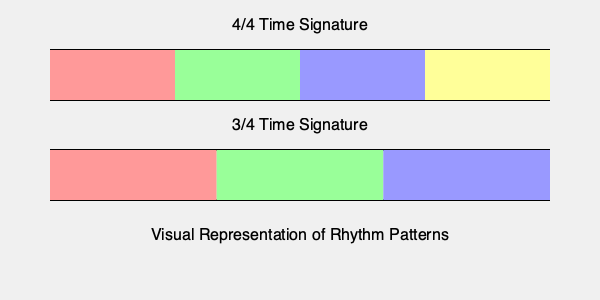Analyze the visual representation of rhythm patterns for 4/4 and 3/4 time signatures shown in the image. If a jazz piece incorporates a polyrhythmic section combining these two time signatures simultaneously, what would be the number of measures required for both patterns to synchronize and start over together? Express your answer in terms of the least common multiple (LCM) of the number of beats in each measure. To solve this problem, we need to follow these steps:

1. Identify the number of beats in each time signature:
   - 4/4 time signature has 4 beats per measure
   - 3/4 time signature has 3 beats per measure

2. Calculate the Least Common Multiple (LCM) of these two numbers:
   - We need to find the LCM of 4 and 3
   - To calculate the LCM, first find the prime factorization of each number:
     4 = 2² and 3 = 3
   - The LCM will include the highest power of each prime factor:
     LCM(4,3) = 2² × 3 = 4 × 3 = 12

3. Interpret the result:
   - The LCM of 12 means that after 12 beats, both patterns will synchronize and start over together
   - In terms of measures:
     - For 4/4 time: 12 beats ÷ 4 beats per measure = 3 measures
     - For 3/4 time: 12 beats ÷ 3 beats per measure = 4 measures

4. Express the answer in terms of LCM:
   The number of measures required for synchronization is equal to the LCM of the number of beats in each measure, which is LCM(4,3) = 12 beats.

This visual representation helps to understand how the two rhythm patterns would align and eventually synchronize, creating a complex polyrhythmic structure often found in jazz and other advanced musical compositions.
Answer: LCM(4,3) = 12 beats 